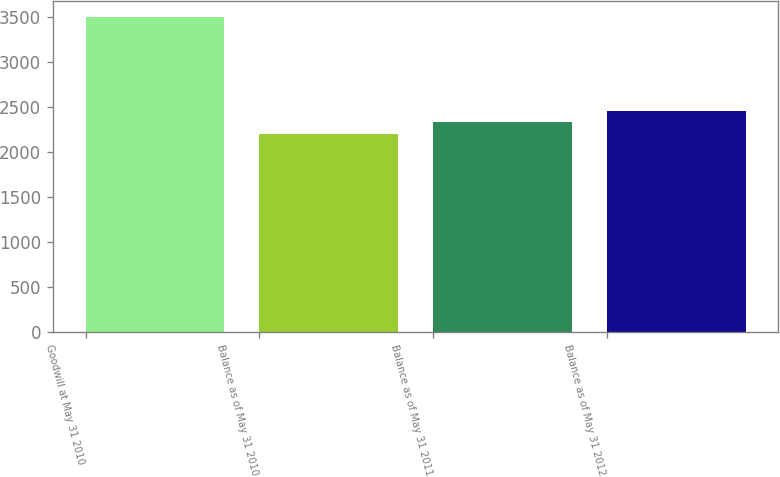Convert chart to OTSL. <chart><loc_0><loc_0><loc_500><loc_500><bar_chart><fcel>Goodwill at May 31 2010<fcel>Balance as of May 31 2010<fcel>Balance as of May 31 2011<fcel>Balance as of May 31 2012<nl><fcel>3510<fcel>2200<fcel>2331<fcel>2462<nl></chart> 